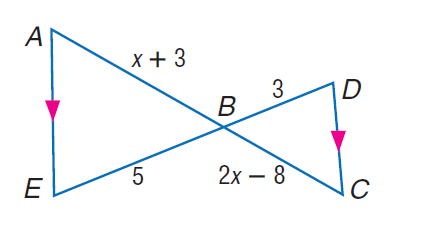Answer the mathemtical geometry problem and directly provide the correct option letter.
Question: Find A B.
Choices: A: 4 B: 6 C: 10 D: 11 C 